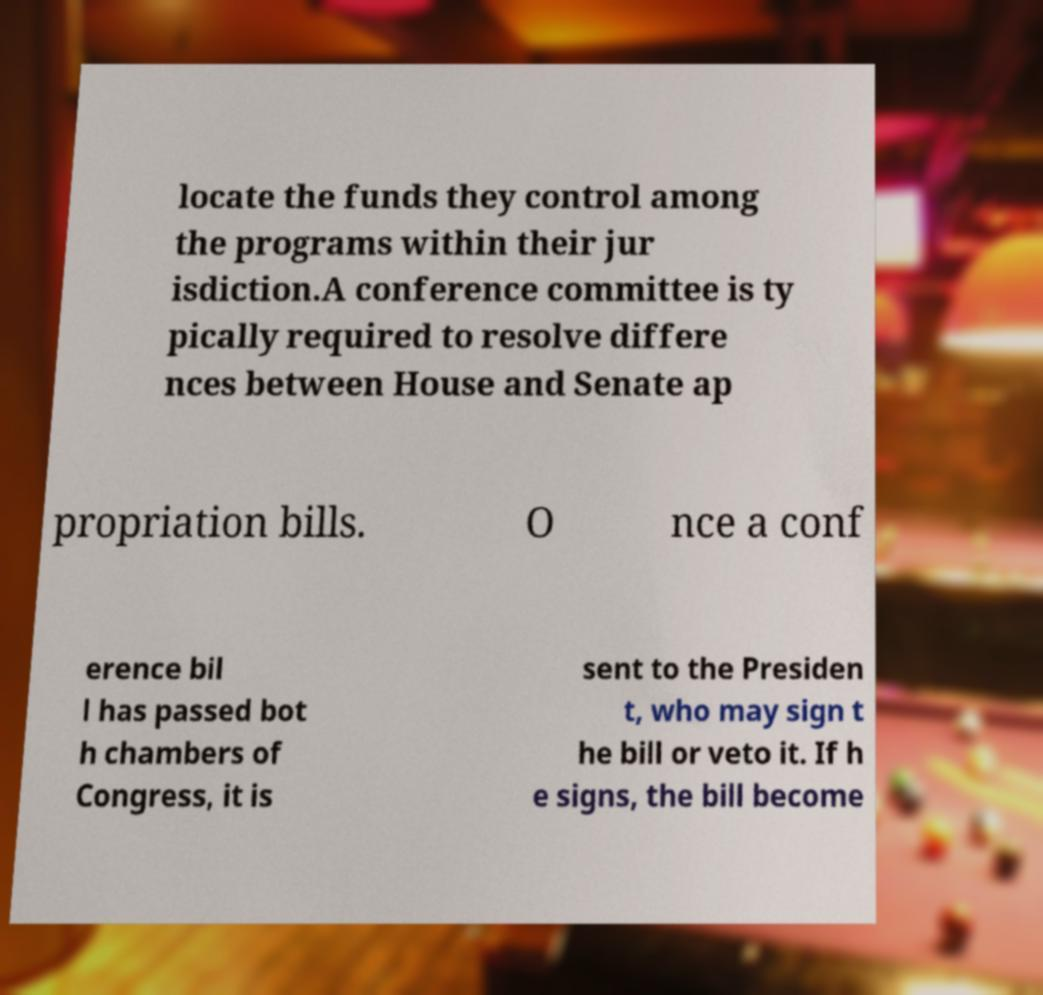I need the written content from this picture converted into text. Can you do that? locate the funds they control among the programs within their jur isdiction.A conference committee is ty pically required to resolve differe nces between House and Senate ap propriation bills. O nce a conf erence bil l has passed bot h chambers of Congress, it is sent to the Presiden t, who may sign t he bill or veto it. If h e signs, the bill become 